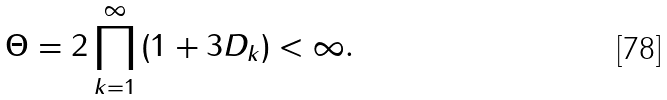<formula> <loc_0><loc_0><loc_500><loc_500>\Theta = 2 \prod _ { k = 1 } ^ { \infty } { ( 1 + 3 D _ { k } ) } < \infty .</formula> 